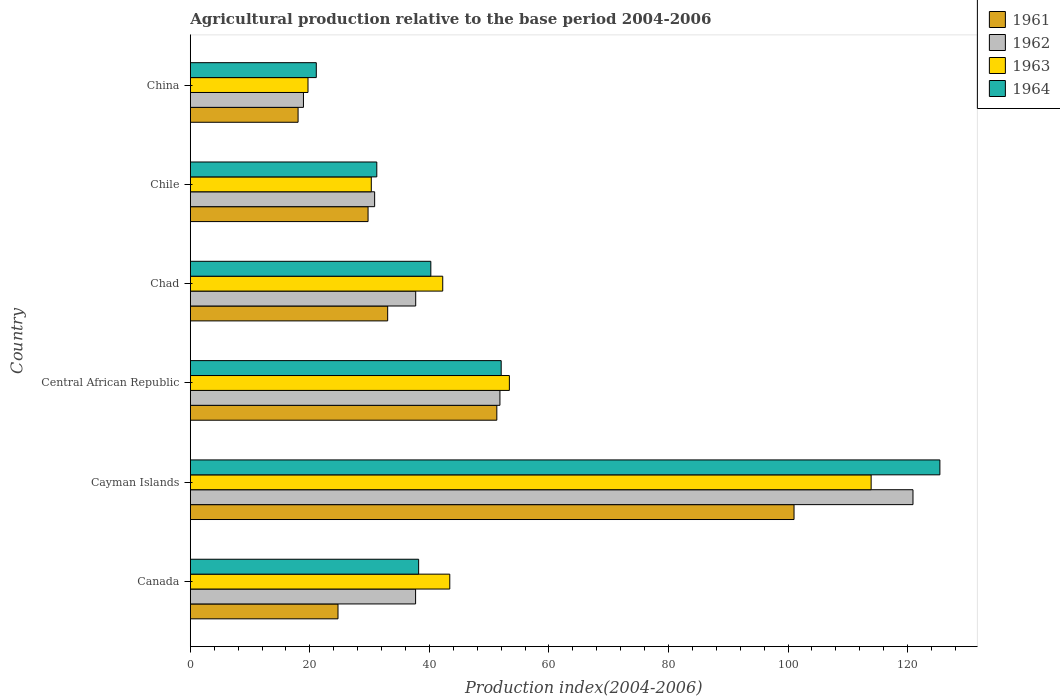How many different coloured bars are there?
Make the answer very short. 4. How many groups of bars are there?
Your answer should be compact. 6. Are the number of bars on each tick of the Y-axis equal?
Keep it short and to the point. Yes. How many bars are there on the 4th tick from the top?
Ensure brevity in your answer.  4. What is the label of the 3rd group of bars from the top?
Offer a terse response. Chad. In how many cases, is the number of bars for a given country not equal to the number of legend labels?
Offer a terse response. 0. What is the agricultural production index in 1961 in Chad?
Provide a succinct answer. 33.02. Across all countries, what is the maximum agricultural production index in 1962?
Keep it short and to the point. 120.9. Across all countries, what is the minimum agricultural production index in 1962?
Your answer should be very brief. 18.93. In which country was the agricultural production index in 1964 maximum?
Provide a succinct answer. Cayman Islands. In which country was the agricultural production index in 1963 minimum?
Offer a very short reply. China. What is the total agricultural production index in 1961 in the graph?
Offer a terse response. 257.78. What is the difference between the agricultural production index in 1962 in Cayman Islands and that in China?
Make the answer very short. 101.97. What is the difference between the agricultural production index in 1963 in Chile and the agricultural production index in 1961 in Central African Republic?
Ensure brevity in your answer.  -21. What is the average agricultural production index in 1963 per country?
Your answer should be very brief. 50.48. What is the difference between the agricultural production index in 1964 and agricultural production index in 1962 in China?
Your answer should be very brief. 2.15. In how many countries, is the agricultural production index in 1962 greater than 92 ?
Your answer should be very brief. 1. What is the ratio of the agricultural production index in 1962 in Cayman Islands to that in Chile?
Keep it short and to the point. 3.92. Is the agricultural production index in 1962 in Canada less than that in China?
Provide a short and direct response. No. Is the difference between the agricultural production index in 1964 in Cayman Islands and Chad greater than the difference between the agricultural production index in 1962 in Cayman Islands and Chad?
Your answer should be very brief. Yes. What is the difference between the highest and the second highest agricultural production index in 1963?
Provide a succinct answer. 60.52. What is the difference between the highest and the lowest agricultural production index in 1962?
Keep it short and to the point. 101.97. Is the sum of the agricultural production index in 1963 in Chad and China greater than the maximum agricultural production index in 1962 across all countries?
Ensure brevity in your answer.  No. Is it the case that in every country, the sum of the agricultural production index in 1963 and agricultural production index in 1962 is greater than the sum of agricultural production index in 1961 and agricultural production index in 1964?
Make the answer very short. No. What does the 2nd bar from the top in Central African Republic represents?
Keep it short and to the point. 1963. What does the 3rd bar from the bottom in Chad represents?
Give a very brief answer. 1963. How many bars are there?
Your response must be concise. 24. Are all the bars in the graph horizontal?
Your response must be concise. Yes. How many countries are there in the graph?
Your answer should be very brief. 6. What is the difference between two consecutive major ticks on the X-axis?
Your answer should be very brief. 20. How are the legend labels stacked?
Provide a succinct answer. Vertical. What is the title of the graph?
Offer a terse response. Agricultural production relative to the base period 2004-2006. Does "1965" appear as one of the legend labels in the graph?
Provide a short and direct response. No. What is the label or title of the X-axis?
Ensure brevity in your answer.  Production index(2004-2006). What is the label or title of the Y-axis?
Provide a succinct answer. Country. What is the Production index(2004-2006) of 1961 in Canada?
Provide a short and direct response. 24.71. What is the Production index(2004-2006) in 1962 in Canada?
Your answer should be very brief. 37.69. What is the Production index(2004-2006) of 1963 in Canada?
Keep it short and to the point. 43.41. What is the Production index(2004-2006) of 1964 in Canada?
Provide a succinct answer. 38.2. What is the Production index(2004-2006) in 1961 in Cayman Islands?
Offer a very short reply. 101. What is the Production index(2004-2006) of 1962 in Cayman Islands?
Your answer should be compact. 120.9. What is the Production index(2004-2006) in 1963 in Cayman Islands?
Offer a very short reply. 113.9. What is the Production index(2004-2006) of 1964 in Cayman Islands?
Your response must be concise. 125.4. What is the Production index(2004-2006) in 1961 in Central African Republic?
Your answer should be very brief. 51.28. What is the Production index(2004-2006) of 1962 in Central African Republic?
Offer a very short reply. 51.8. What is the Production index(2004-2006) of 1963 in Central African Republic?
Your response must be concise. 53.38. What is the Production index(2004-2006) in 1964 in Central African Republic?
Make the answer very short. 52.01. What is the Production index(2004-2006) in 1961 in Chad?
Keep it short and to the point. 33.02. What is the Production index(2004-2006) in 1962 in Chad?
Keep it short and to the point. 37.71. What is the Production index(2004-2006) of 1963 in Chad?
Give a very brief answer. 42.23. What is the Production index(2004-2006) in 1964 in Chad?
Offer a very short reply. 40.24. What is the Production index(2004-2006) of 1961 in Chile?
Make the answer very short. 29.74. What is the Production index(2004-2006) of 1962 in Chile?
Offer a terse response. 30.84. What is the Production index(2004-2006) in 1963 in Chile?
Your response must be concise. 30.28. What is the Production index(2004-2006) in 1964 in Chile?
Provide a short and direct response. 31.2. What is the Production index(2004-2006) of 1961 in China?
Offer a terse response. 18.03. What is the Production index(2004-2006) in 1962 in China?
Keep it short and to the point. 18.93. What is the Production index(2004-2006) in 1963 in China?
Provide a succinct answer. 19.69. What is the Production index(2004-2006) of 1964 in China?
Your answer should be compact. 21.08. Across all countries, what is the maximum Production index(2004-2006) of 1961?
Keep it short and to the point. 101. Across all countries, what is the maximum Production index(2004-2006) of 1962?
Offer a terse response. 120.9. Across all countries, what is the maximum Production index(2004-2006) in 1963?
Your answer should be compact. 113.9. Across all countries, what is the maximum Production index(2004-2006) of 1964?
Make the answer very short. 125.4. Across all countries, what is the minimum Production index(2004-2006) of 1961?
Keep it short and to the point. 18.03. Across all countries, what is the minimum Production index(2004-2006) in 1962?
Keep it short and to the point. 18.93. Across all countries, what is the minimum Production index(2004-2006) of 1963?
Provide a succinct answer. 19.69. Across all countries, what is the minimum Production index(2004-2006) in 1964?
Your answer should be very brief. 21.08. What is the total Production index(2004-2006) in 1961 in the graph?
Ensure brevity in your answer.  257.78. What is the total Production index(2004-2006) of 1962 in the graph?
Your answer should be compact. 297.87. What is the total Production index(2004-2006) of 1963 in the graph?
Offer a very short reply. 302.89. What is the total Production index(2004-2006) of 1964 in the graph?
Make the answer very short. 308.13. What is the difference between the Production index(2004-2006) in 1961 in Canada and that in Cayman Islands?
Ensure brevity in your answer.  -76.29. What is the difference between the Production index(2004-2006) in 1962 in Canada and that in Cayman Islands?
Keep it short and to the point. -83.21. What is the difference between the Production index(2004-2006) of 1963 in Canada and that in Cayman Islands?
Your answer should be very brief. -70.49. What is the difference between the Production index(2004-2006) in 1964 in Canada and that in Cayman Islands?
Your answer should be compact. -87.2. What is the difference between the Production index(2004-2006) in 1961 in Canada and that in Central African Republic?
Your answer should be very brief. -26.57. What is the difference between the Production index(2004-2006) of 1962 in Canada and that in Central African Republic?
Your answer should be compact. -14.11. What is the difference between the Production index(2004-2006) of 1963 in Canada and that in Central African Republic?
Keep it short and to the point. -9.97. What is the difference between the Production index(2004-2006) of 1964 in Canada and that in Central African Republic?
Your answer should be compact. -13.81. What is the difference between the Production index(2004-2006) in 1961 in Canada and that in Chad?
Provide a succinct answer. -8.31. What is the difference between the Production index(2004-2006) in 1962 in Canada and that in Chad?
Provide a short and direct response. -0.02. What is the difference between the Production index(2004-2006) of 1963 in Canada and that in Chad?
Offer a terse response. 1.18. What is the difference between the Production index(2004-2006) of 1964 in Canada and that in Chad?
Offer a terse response. -2.04. What is the difference between the Production index(2004-2006) in 1961 in Canada and that in Chile?
Make the answer very short. -5.03. What is the difference between the Production index(2004-2006) of 1962 in Canada and that in Chile?
Ensure brevity in your answer.  6.85. What is the difference between the Production index(2004-2006) in 1963 in Canada and that in Chile?
Give a very brief answer. 13.13. What is the difference between the Production index(2004-2006) of 1964 in Canada and that in Chile?
Ensure brevity in your answer.  7. What is the difference between the Production index(2004-2006) of 1961 in Canada and that in China?
Provide a succinct answer. 6.68. What is the difference between the Production index(2004-2006) of 1962 in Canada and that in China?
Offer a very short reply. 18.76. What is the difference between the Production index(2004-2006) of 1963 in Canada and that in China?
Offer a terse response. 23.72. What is the difference between the Production index(2004-2006) in 1964 in Canada and that in China?
Your answer should be very brief. 17.12. What is the difference between the Production index(2004-2006) in 1961 in Cayman Islands and that in Central African Republic?
Provide a short and direct response. 49.72. What is the difference between the Production index(2004-2006) in 1962 in Cayman Islands and that in Central African Republic?
Provide a short and direct response. 69.1. What is the difference between the Production index(2004-2006) of 1963 in Cayman Islands and that in Central African Republic?
Offer a very short reply. 60.52. What is the difference between the Production index(2004-2006) of 1964 in Cayman Islands and that in Central African Republic?
Offer a terse response. 73.39. What is the difference between the Production index(2004-2006) in 1961 in Cayman Islands and that in Chad?
Ensure brevity in your answer.  67.98. What is the difference between the Production index(2004-2006) in 1962 in Cayman Islands and that in Chad?
Give a very brief answer. 83.19. What is the difference between the Production index(2004-2006) of 1963 in Cayman Islands and that in Chad?
Ensure brevity in your answer.  71.67. What is the difference between the Production index(2004-2006) of 1964 in Cayman Islands and that in Chad?
Ensure brevity in your answer.  85.16. What is the difference between the Production index(2004-2006) of 1961 in Cayman Islands and that in Chile?
Your response must be concise. 71.26. What is the difference between the Production index(2004-2006) in 1962 in Cayman Islands and that in Chile?
Make the answer very short. 90.06. What is the difference between the Production index(2004-2006) in 1963 in Cayman Islands and that in Chile?
Offer a terse response. 83.62. What is the difference between the Production index(2004-2006) in 1964 in Cayman Islands and that in Chile?
Your answer should be very brief. 94.2. What is the difference between the Production index(2004-2006) of 1961 in Cayman Islands and that in China?
Your response must be concise. 82.97. What is the difference between the Production index(2004-2006) in 1962 in Cayman Islands and that in China?
Give a very brief answer. 101.97. What is the difference between the Production index(2004-2006) of 1963 in Cayman Islands and that in China?
Keep it short and to the point. 94.21. What is the difference between the Production index(2004-2006) in 1964 in Cayman Islands and that in China?
Your answer should be compact. 104.32. What is the difference between the Production index(2004-2006) in 1961 in Central African Republic and that in Chad?
Your response must be concise. 18.26. What is the difference between the Production index(2004-2006) in 1962 in Central African Republic and that in Chad?
Provide a succinct answer. 14.09. What is the difference between the Production index(2004-2006) in 1963 in Central African Republic and that in Chad?
Your answer should be compact. 11.15. What is the difference between the Production index(2004-2006) of 1964 in Central African Republic and that in Chad?
Give a very brief answer. 11.77. What is the difference between the Production index(2004-2006) of 1961 in Central African Republic and that in Chile?
Provide a succinct answer. 21.54. What is the difference between the Production index(2004-2006) in 1962 in Central African Republic and that in Chile?
Provide a succinct answer. 20.96. What is the difference between the Production index(2004-2006) in 1963 in Central African Republic and that in Chile?
Your answer should be very brief. 23.1. What is the difference between the Production index(2004-2006) of 1964 in Central African Republic and that in Chile?
Keep it short and to the point. 20.81. What is the difference between the Production index(2004-2006) in 1961 in Central African Republic and that in China?
Give a very brief answer. 33.25. What is the difference between the Production index(2004-2006) in 1962 in Central African Republic and that in China?
Provide a short and direct response. 32.87. What is the difference between the Production index(2004-2006) in 1963 in Central African Republic and that in China?
Make the answer very short. 33.69. What is the difference between the Production index(2004-2006) of 1964 in Central African Republic and that in China?
Keep it short and to the point. 30.93. What is the difference between the Production index(2004-2006) in 1961 in Chad and that in Chile?
Your answer should be very brief. 3.28. What is the difference between the Production index(2004-2006) in 1962 in Chad and that in Chile?
Offer a terse response. 6.87. What is the difference between the Production index(2004-2006) in 1963 in Chad and that in Chile?
Keep it short and to the point. 11.95. What is the difference between the Production index(2004-2006) in 1964 in Chad and that in Chile?
Your answer should be very brief. 9.04. What is the difference between the Production index(2004-2006) in 1961 in Chad and that in China?
Make the answer very short. 14.99. What is the difference between the Production index(2004-2006) in 1962 in Chad and that in China?
Make the answer very short. 18.78. What is the difference between the Production index(2004-2006) of 1963 in Chad and that in China?
Provide a succinct answer. 22.54. What is the difference between the Production index(2004-2006) of 1964 in Chad and that in China?
Your answer should be very brief. 19.16. What is the difference between the Production index(2004-2006) of 1961 in Chile and that in China?
Offer a very short reply. 11.71. What is the difference between the Production index(2004-2006) in 1962 in Chile and that in China?
Keep it short and to the point. 11.91. What is the difference between the Production index(2004-2006) in 1963 in Chile and that in China?
Offer a terse response. 10.59. What is the difference between the Production index(2004-2006) of 1964 in Chile and that in China?
Provide a short and direct response. 10.12. What is the difference between the Production index(2004-2006) in 1961 in Canada and the Production index(2004-2006) in 1962 in Cayman Islands?
Provide a succinct answer. -96.19. What is the difference between the Production index(2004-2006) of 1961 in Canada and the Production index(2004-2006) of 1963 in Cayman Islands?
Offer a very short reply. -89.19. What is the difference between the Production index(2004-2006) in 1961 in Canada and the Production index(2004-2006) in 1964 in Cayman Islands?
Provide a succinct answer. -100.69. What is the difference between the Production index(2004-2006) of 1962 in Canada and the Production index(2004-2006) of 1963 in Cayman Islands?
Offer a terse response. -76.21. What is the difference between the Production index(2004-2006) in 1962 in Canada and the Production index(2004-2006) in 1964 in Cayman Islands?
Offer a very short reply. -87.71. What is the difference between the Production index(2004-2006) in 1963 in Canada and the Production index(2004-2006) in 1964 in Cayman Islands?
Offer a terse response. -81.99. What is the difference between the Production index(2004-2006) of 1961 in Canada and the Production index(2004-2006) of 1962 in Central African Republic?
Keep it short and to the point. -27.09. What is the difference between the Production index(2004-2006) of 1961 in Canada and the Production index(2004-2006) of 1963 in Central African Republic?
Keep it short and to the point. -28.67. What is the difference between the Production index(2004-2006) of 1961 in Canada and the Production index(2004-2006) of 1964 in Central African Republic?
Offer a very short reply. -27.3. What is the difference between the Production index(2004-2006) of 1962 in Canada and the Production index(2004-2006) of 1963 in Central African Republic?
Ensure brevity in your answer.  -15.69. What is the difference between the Production index(2004-2006) of 1962 in Canada and the Production index(2004-2006) of 1964 in Central African Republic?
Give a very brief answer. -14.32. What is the difference between the Production index(2004-2006) of 1963 in Canada and the Production index(2004-2006) of 1964 in Central African Republic?
Give a very brief answer. -8.6. What is the difference between the Production index(2004-2006) in 1961 in Canada and the Production index(2004-2006) in 1962 in Chad?
Offer a terse response. -13. What is the difference between the Production index(2004-2006) in 1961 in Canada and the Production index(2004-2006) in 1963 in Chad?
Keep it short and to the point. -17.52. What is the difference between the Production index(2004-2006) in 1961 in Canada and the Production index(2004-2006) in 1964 in Chad?
Offer a very short reply. -15.53. What is the difference between the Production index(2004-2006) in 1962 in Canada and the Production index(2004-2006) in 1963 in Chad?
Offer a terse response. -4.54. What is the difference between the Production index(2004-2006) in 1962 in Canada and the Production index(2004-2006) in 1964 in Chad?
Provide a short and direct response. -2.55. What is the difference between the Production index(2004-2006) of 1963 in Canada and the Production index(2004-2006) of 1964 in Chad?
Your response must be concise. 3.17. What is the difference between the Production index(2004-2006) in 1961 in Canada and the Production index(2004-2006) in 1962 in Chile?
Your answer should be very brief. -6.13. What is the difference between the Production index(2004-2006) of 1961 in Canada and the Production index(2004-2006) of 1963 in Chile?
Offer a very short reply. -5.57. What is the difference between the Production index(2004-2006) of 1961 in Canada and the Production index(2004-2006) of 1964 in Chile?
Your answer should be compact. -6.49. What is the difference between the Production index(2004-2006) in 1962 in Canada and the Production index(2004-2006) in 1963 in Chile?
Give a very brief answer. 7.41. What is the difference between the Production index(2004-2006) in 1962 in Canada and the Production index(2004-2006) in 1964 in Chile?
Ensure brevity in your answer.  6.49. What is the difference between the Production index(2004-2006) of 1963 in Canada and the Production index(2004-2006) of 1964 in Chile?
Your response must be concise. 12.21. What is the difference between the Production index(2004-2006) in 1961 in Canada and the Production index(2004-2006) in 1962 in China?
Make the answer very short. 5.78. What is the difference between the Production index(2004-2006) of 1961 in Canada and the Production index(2004-2006) of 1963 in China?
Ensure brevity in your answer.  5.02. What is the difference between the Production index(2004-2006) in 1961 in Canada and the Production index(2004-2006) in 1964 in China?
Your answer should be compact. 3.63. What is the difference between the Production index(2004-2006) in 1962 in Canada and the Production index(2004-2006) in 1964 in China?
Your response must be concise. 16.61. What is the difference between the Production index(2004-2006) of 1963 in Canada and the Production index(2004-2006) of 1964 in China?
Your answer should be compact. 22.33. What is the difference between the Production index(2004-2006) in 1961 in Cayman Islands and the Production index(2004-2006) in 1962 in Central African Republic?
Your answer should be compact. 49.2. What is the difference between the Production index(2004-2006) in 1961 in Cayman Islands and the Production index(2004-2006) in 1963 in Central African Republic?
Your answer should be compact. 47.62. What is the difference between the Production index(2004-2006) in 1961 in Cayman Islands and the Production index(2004-2006) in 1964 in Central African Republic?
Your answer should be compact. 48.99. What is the difference between the Production index(2004-2006) in 1962 in Cayman Islands and the Production index(2004-2006) in 1963 in Central African Republic?
Ensure brevity in your answer.  67.52. What is the difference between the Production index(2004-2006) in 1962 in Cayman Islands and the Production index(2004-2006) in 1964 in Central African Republic?
Offer a very short reply. 68.89. What is the difference between the Production index(2004-2006) in 1963 in Cayman Islands and the Production index(2004-2006) in 1964 in Central African Republic?
Provide a succinct answer. 61.89. What is the difference between the Production index(2004-2006) in 1961 in Cayman Islands and the Production index(2004-2006) in 1962 in Chad?
Keep it short and to the point. 63.29. What is the difference between the Production index(2004-2006) in 1961 in Cayman Islands and the Production index(2004-2006) in 1963 in Chad?
Your answer should be compact. 58.77. What is the difference between the Production index(2004-2006) in 1961 in Cayman Islands and the Production index(2004-2006) in 1964 in Chad?
Make the answer very short. 60.76. What is the difference between the Production index(2004-2006) in 1962 in Cayman Islands and the Production index(2004-2006) in 1963 in Chad?
Keep it short and to the point. 78.67. What is the difference between the Production index(2004-2006) of 1962 in Cayman Islands and the Production index(2004-2006) of 1964 in Chad?
Give a very brief answer. 80.66. What is the difference between the Production index(2004-2006) of 1963 in Cayman Islands and the Production index(2004-2006) of 1964 in Chad?
Provide a succinct answer. 73.66. What is the difference between the Production index(2004-2006) in 1961 in Cayman Islands and the Production index(2004-2006) in 1962 in Chile?
Give a very brief answer. 70.16. What is the difference between the Production index(2004-2006) in 1961 in Cayman Islands and the Production index(2004-2006) in 1963 in Chile?
Make the answer very short. 70.72. What is the difference between the Production index(2004-2006) of 1961 in Cayman Islands and the Production index(2004-2006) of 1964 in Chile?
Offer a terse response. 69.8. What is the difference between the Production index(2004-2006) of 1962 in Cayman Islands and the Production index(2004-2006) of 1963 in Chile?
Make the answer very short. 90.62. What is the difference between the Production index(2004-2006) of 1962 in Cayman Islands and the Production index(2004-2006) of 1964 in Chile?
Offer a terse response. 89.7. What is the difference between the Production index(2004-2006) in 1963 in Cayman Islands and the Production index(2004-2006) in 1964 in Chile?
Provide a short and direct response. 82.7. What is the difference between the Production index(2004-2006) of 1961 in Cayman Islands and the Production index(2004-2006) of 1962 in China?
Offer a terse response. 82.07. What is the difference between the Production index(2004-2006) in 1961 in Cayman Islands and the Production index(2004-2006) in 1963 in China?
Your response must be concise. 81.31. What is the difference between the Production index(2004-2006) in 1961 in Cayman Islands and the Production index(2004-2006) in 1964 in China?
Make the answer very short. 79.92. What is the difference between the Production index(2004-2006) of 1962 in Cayman Islands and the Production index(2004-2006) of 1963 in China?
Provide a succinct answer. 101.21. What is the difference between the Production index(2004-2006) in 1962 in Cayman Islands and the Production index(2004-2006) in 1964 in China?
Provide a short and direct response. 99.82. What is the difference between the Production index(2004-2006) of 1963 in Cayman Islands and the Production index(2004-2006) of 1964 in China?
Your answer should be very brief. 92.82. What is the difference between the Production index(2004-2006) of 1961 in Central African Republic and the Production index(2004-2006) of 1962 in Chad?
Provide a short and direct response. 13.57. What is the difference between the Production index(2004-2006) of 1961 in Central African Republic and the Production index(2004-2006) of 1963 in Chad?
Offer a terse response. 9.05. What is the difference between the Production index(2004-2006) in 1961 in Central African Republic and the Production index(2004-2006) in 1964 in Chad?
Make the answer very short. 11.04. What is the difference between the Production index(2004-2006) of 1962 in Central African Republic and the Production index(2004-2006) of 1963 in Chad?
Keep it short and to the point. 9.57. What is the difference between the Production index(2004-2006) in 1962 in Central African Republic and the Production index(2004-2006) in 1964 in Chad?
Keep it short and to the point. 11.56. What is the difference between the Production index(2004-2006) of 1963 in Central African Republic and the Production index(2004-2006) of 1964 in Chad?
Offer a terse response. 13.14. What is the difference between the Production index(2004-2006) in 1961 in Central African Republic and the Production index(2004-2006) in 1962 in Chile?
Make the answer very short. 20.44. What is the difference between the Production index(2004-2006) in 1961 in Central African Republic and the Production index(2004-2006) in 1963 in Chile?
Give a very brief answer. 21. What is the difference between the Production index(2004-2006) in 1961 in Central African Republic and the Production index(2004-2006) in 1964 in Chile?
Your answer should be compact. 20.08. What is the difference between the Production index(2004-2006) of 1962 in Central African Republic and the Production index(2004-2006) of 1963 in Chile?
Give a very brief answer. 21.52. What is the difference between the Production index(2004-2006) of 1962 in Central African Republic and the Production index(2004-2006) of 1964 in Chile?
Your answer should be very brief. 20.6. What is the difference between the Production index(2004-2006) in 1963 in Central African Republic and the Production index(2004-2006) in 1964 in Chile?
Your response must be concise. 22.18. What is the difference between the Production index(2004-2006) of 1961 in Central African Republic and the Production index(2004-2006) of 1962 in China?
Offer a very short reply. 32.35. What is the difference between the Production index(2004-2006) in 1961 in Central African Republic and the Production index(2004-2006) in 1963 in China?
Your answer should be very brief. 31.59. What is the difference between the Production index(2004-2006) in 1961 in Central African Republic and the Production index(2004-2006) in 1964 in China?
Give a very brief answer. 30.2. What is the difference between the Production index(2004-2006) of 1962 in Central African Republic and the Production index(2004-2006) of 1963 in China?
Ensure brevity in your answer.  32.11. What is the difference between the Production index(2004-2006) of 1962 in Central African Republic and the Production index(2004-2006) of 1964 in China?
Ensure brevity in your answer.  30.72. What is the difference between the Production index(2004-2006) in 1963 in Central African Republic and the Production index(2004-2006) in 1964 in China?
Offer a very short reply. 32.3. What is the difference between the Production index(2004-2006) of 1961 in Chad and the Production index(2004-2006) of 1962 in Chile?
Offer a very short reply. 2.18. What is the difference between the Production index(2004-2006) in 1961 in Chad and the Production index(2004-2006) in 1963 in Chile?
Provide a short and direct response. 2.74. What is the difference between the Production index(2004-2006) in 1961 in Chad and the Production index(2004-2006) in 1964 in Chile?
Make the answer very short. 1.82. What is the difference between the Production index(2004-2006) of 1962 in Chad and the Production index(2004-2006) of 1963 in Chile?
Your answer should be compact. 7.43. What is the difference between the Production index(2004-2006) of 1962 in Chad and the Production index(2004-2006) of 1964 in Chile?
Offer a terse response. 6.51. What is the difference between the Production index(2004-2006) of 1963 in Chad and the Production index(2004-2006) of 1964 in Chile?
Provide a short and direct response. 11.03. What is the difference between the Production index(2004-2006) of 1961 in Chad and the Production index(2004-2006) of 1962 in China?
Give a very brief answer. 14.09. What is the difference between the Production index(2004-2006) of 1961 in Chad and the Production index(2004-2006) of 1963 in China?
Give a very brief answer. 13.33. What is the difference between the Production index(2004-2006) of 1961 in Chad and the Production index(2004-2006) of 1964 in China?
Make the answer very short. 11.94. What is the difference between the Production index(2004-2006) of 1962 in Chad and the Production index(2004-2006) of 1963 in China?
Ensure brevity in your answer.  18.02. What is the difference between the Production index(2004-2006) in 1962 in Chad and the Production index(2004-2006) in 1964 in China?
Your answer should be compact. 16.63. What is the difference between the Production index(2004-2006) in 1963 in Chad and the Production index(2004-2006) in 1964 in China?
Your response must be concise. 21.15. What is the difference between the Production index(2004-2006) of 1961 in Chile and the Production index(2004-2006) of 1962 in China?
Your answer should be compact. 10.81. What is the difference between the Production index(2004-2006) in 1961 in Chile and the Production index(2004-2006) in 1963 in China?
Your answer should be very brief. 10.05. What is the difference between the Production index(2004-2006) in 1961 in Chile and the Production index(2004-2006) in 1964 in China?
Ensure brevity in your answer.  8.66. What is the difference between the Production index(2004-2006) of 1962 in Chile and the Production index(2004-2006) of 1963 in China?
Your response must be concise. 11.15. What is the difference between the Production index(2004-2006) of 1962 in Chile and the Production index(2004-2006) of 1964 in China?
Provide a short and direct response. 9.76. What is the difference between the Production index(2004-2006) of 1963 in Chile and the Production index(2004-2006) of 1964 in China?
Provide a short and direct response. 9.2. What is the average Production index(2004-2006) in 1961 per country?
Provide a succinct answer. 42.96. What is the average Production index(2004-2006) of 1962 per country?
Provide a succinct answer. 49.65. What is the average Production index(2004-2006) in 1963 per country?
Provide a succinct answer. 50.48. What is the average Production index(2004-2006) in 1964 per country?
Your answer should be compact. 51.35. What is the difference between the Production index(2004-2006) of 1961 and Production index(2004-2006) of 1962 in Canada?
Your answer should be very brief. -12.98. What is the difference between the Production index(2004-2006) of 1961 and Production index(2004-2006) of 1963 in Canada?
Give a very brief answer. -18.7. What is the difference between the Production index(2004-2006) in 1961 and Production index(2004-2006) in 1964 in Canada?
Your answer should be compact. -13.49. What is the difference between the Production index(2004-2006) of 1962 and Production index(2004-2006) of 1963 in Canada?
Make the answer very short. -5.72. What is the difference between the Production index(2004-2006) of 1962 and Production index(2004-2006) of 1964 in Canada?
Ensure brevity in your answer.  -0.51. What is the difference between the Production index(2004-2006) in 1963 and Production index(2004-2006) in 1964 in Canada?
Make the answer very short. 5.21. What is the difference between the Production index(2004-2006) of 1961 and Production index(2004-2006) of 1962 in Cayman Islands?
Ensure brevity in your answer.  -19.9. What is the difference between the Production index(2004-2006) in 1961 and Production index(2004-2006) in 1963 in Cayman Islands?
Ensure brevity in your answer.  -12.9. What is the difference between the Production index(2004-2006) in 1961 and Production index(2004-2006) in 1964 in Cayman Islands?
Offer a terse response. -24.4. What is the difference between the Production index(2004-2006) of 1962 and Production index(2004-2006) of 1963 in Cayman Islands?
Make the answer very short. 7. What is the difference between the Production index(2004-2006) of 1962 and Production index(2004-2006) of 1964 in Cayman Islands?
Provide a succinct answer. -4.5. What is the difference between the Production index(2004-2006) in 1961 and Production index(2004-2006) in 1962 in Central African Republic?
Your answer should be compact. -0.52. What is the difference between the Production index(2004-2006) of 1961 and Production index(2004-2006) of 1964 in Central African Republic?
Offer a very short reply. -0.73. What is the difference between the Production index(2004-2006) of 1962 and Production index(2004-2006) of 1963 in Central African Republic?
Your answer should be very brief. -1.58. What is the difference between the Production index(2004-2006) of 1962 and Production index(2004-2006) of 1964 in Central African Republic?
Offer a very short reply. -0.21. What is the difference between the Production index(2004-2006) of 1963 and Production index(2004-2006) of 1964 in Central African Republic?
Make the answer very short. 1.37. What is the difference between the Production index(2004-2006) of 1961 and Production index(2004-2006) of 1962 in Chad?
Your answer should be very brief. -4.69. What is the difference between the Production index(2004-2006) of 1961 and Production index(2004-2006) of 1963 in Chad?
Provide a short and direct response. -9.21. What is the difference between the Production index(2004-2006) of 1961 and Production index(2004-2006) of 1964 in Chad?
Provide a succinct answer. -7.22. What is the difference between the Production index(2004-2006) of 1962 and Production index(2004-2006) of 1963 in Chad?
Your answer should be very brief. -4.52. What is the difference between the Production index(2004-2006) of 1962 and Production index(2004-2006) of 1964 in Chad?
Keep it short and to the point. -2.53. What is the difference between the Production index(2004-2006) of 1963 and Production index(2004-2006) of 1964 in Chad?
Offer a very short reply. 1.99. What is the difference between the Production index(2004-2006) of 1961 and Production index(2004-2006) of 1963 in Chile?
Provide a short and direct response. -0.54. What is the difference between the Production index(2004-2006) in 1961 and Production index(2004-2006) in 1964 in Chile?
Your answer should be very brief. -1.46. What is the difference between the Production index(2004-2006) of 1962 and Production index(2004-2006) of 1963 in Chile?
Give a very brief answer. 0.56. What is the difference between the Production index(2004-2006) of 1962 and Production index(2004-2006) of 1964 in Chile?
Ensure brevity in your answer.  -0.36. What is the difference between the Production index(2004-2006) in 1963 and Production index(2004-2006) in 1964 in Chile?
Ensure brevity in your answer.  -0.92. What is the difference between the Production index(2004-2006) in 1961 and Production index(2004-2006) in 1963 in China?
Keep it short and to the point. -1.66. What is the difference between the Production index(2004-2006) of 1961 and Production index(2004-2006) of 1964 in China?
Your answer should be very brief. -3.05. What is the difference between the Production index(2004-2006) of 1962 and Production index(2004-2006) of 1963 in China?
Your answer should be compact. -0.76. What is the difference between the Production index(2004-2006) of 1962 and Production index(2004-2006) of 1964 in China?
Offer a very short reply. -2.15. What is the difference between the Production index(2004-2006) of 1963 and Production index(2004-2006) of 1964 in China?
Offer a terse response. -1.39. What is the ratio of the Production index(2004-2006) of 1961 in Canada to that in Cayman Islands?
Provide a succinct answer. 0.24. What is the ratio of the Production index(2004-2006) in 1962 in Canada to that in Cayman Islands?
Your response must be concise. 0.31. What is the ratio of the Production index(2004-2006) in 1963 in Canada to that in Cayman Islands?
Provide a short and direct response. 0.38. What is the ratio of the Production index(2004-2006) in 1964 in Canada to that in Cayman Islands?
Your response must be concise. 0.3. What is the ratio of the Production index(2004-2006) in 1961 in Canada to that in Central African Republic?
Provide a succinct answer. 0.48. What is the ratio of the Production index(2004-2006) of 1962 in Canada to that in Central African Republic?
Offer a very short reply. 0.73. What is the ratio of the Production index(2004-2006) in 1963 in Canada to that in Central African Republic?
Ensure brevity in your answer.  0.81. What is the ratio of the Production index(2004-2006) in 1964 in Canada to that in Central African Republic?
Your response must be concise. 0.73. What is the ratio of the Production index(2004-2006) of 1961 in Canada to that in Chad?
Your answer should be compact. 0.75. What is the ratio of the Production index(2004-2006) of 1963 in Canada to that in Chad?
Your answer should be very brief. 1.03. What is the ratio of the Production index(2004-2006) in 1964 in Canada to that in Chad?
Give a very brief answer. 0.95. What is the ratio of the Production index(2004-2006) in 1961 in Canada to that in Chile?
Keep it short and to the point. 0.83. What is the ratio of the Production index(2004-2006) in 1962 in Canada to that in Chile?
Offer a terse response. 1.22. What is the ratio of the Production index(2004-2006) of 1963 in Canada to that in Chile?
Your answer should be compact. 1.43. What is the ratio of the Production index(2004-2006) in 1964 in Canada to that in Chile?
Give a very brief answer. 1.22. What is the ratio of the Production index(2004-2006) of 1961 in Canada to that in China?
Give a very brief answer. 1.37. What is the ratio of the Production index(2004-2006) of 1962 in Canada to that in China?
Offer a very short reply. 1.99. What is the ratio of the Production index(2004-2006) of 1963 in Canada to that in China?
Your answer should be very brief. 2.2. What is the ratio of the Production index(2004-2006) in 1964 in Canada to that in China?
Provide a succinct answer. 1.81. What is the ratio of the Production index(2004-2006) in 1961 in Cayman Islands to that in Central African Republic?
Offer a terse response. 1.97. What is the ratio of the Production index(2004-2006) in 1962 in Cayman Islands to that in Central African Republic?
Give a very brief answer. 2.33. What is the ratio of the Production index(2004-2006) of 1963 in Cayman Islands to that in Central African Republic?
Make the answer very short. 2.13. What is the ratio of the Production index(2004-2006) of 1964 in Cayman Islands to that in Central African Republic?
Your answer should be very brief. 2.41. What is the ratio of the Production index(2004-2006) in 1961 in Cayman Islands to that in Chad?
Offer a terse response. 3.06. What is the ratio of the Production index(2004-2006) in 1962 in Cayman Islands to that in Chad?
Your answer should be very brief. 3.21. What is the ratio of the Production index(2004-2006) in 1963 in Cayman Islands to that in Chad?
Your response must be concise. 2.7. What is the ratio of the Production index(2004-2006) in 1964 in Cayman Islands to that in Chad?
Keep it short and to the point. 3.12. What is the ratio of the Production index(2004-2006) in 1961 in Cayman Islands to that in Chile?
Your answer should be compact. 3.4. What is the ratio of the Production index(2004-2006) of 1962 in Cayman Islands to that in Chile?
Offer a very short reply. 3.92. What is the ratio of the Production index(2004-2006) of 1963 in Cayman Islands to that in Chile?
Give a very brief answer. 3.76. What is the ratio of the Production index(2004-2006) of 1964 in Cayman Islands to that in Chile?
Make the answer very short. 4.02. What is the ratio of the Production index(2004-2006) in 1961 in Cayman Islands to that in China?
Provide a short and direct response. 5.6. What is the ratio of the Production index(2004-2006) in 1962 in Cayman Islands to that in China?
Give a very brief answer. 6.39. What is the ratio of the Production index(2004-2006) of 1963 in Cayman Islands to that in China?
Keep it short and to the point. 5.78. What is the ratio of the Production index(2004-2006) in 1964 in Cayman Islands to that in China?
Offer a terse response. 5.95. What is the ratio of the Production index(2004-2006) of 1961 in Central African Republic to that in Chad?
Ensure brevity in your answer.  1.55. What is the ratio of the Production index(2004-2006) of 1962 in Central African Republic to that in Chad?
Provide a succinct answer. 1.37. What is the ratio of the Production index(2004-2006) in 1963 in Central African Republic to that in Chad?
Ensure brevity in your answer.  1.26. What is the ratio of the Production index(2004-2006) of 1964 in Central African Republic to that in Chad?
Give a very brief answer. 1.29. What is the ratio of the Production index(2004-2006) of 1961 in Central African Republic to that in Chile?
Provide a succinct answer. 1.72. What is the ratio of the Production index(2004-2006) in 1962 in Central African Republic to that in Chile?
Give a very brief answer. 1.68. What is the ratio of the Production index(2004-2006) in 1963 in Central African Republic to that in Chile?
Provide a short and direct response. 1.76. What is the ratio of the Production index(2004-2006) in 1964 in Central African Republic to that in Chile?
Offer a terse response. 1.67. What is the ratio of the Production index(2004-2006) of 1961 in Central African Republic to that in China?
Offer a very short reply. 2.84. What is the ratio of the Production index(2004-2006) in 1962 in Central African Republic to that in China?
Offer a very short reply. 2.74. What is the ratio of the Production index(2004-2006) of 1963 in Central African Republic to that in China?
Provide a succinct answer. 2.71. What is the ratio of the Production index(2004-2006) of 1964 in Central African Republic to that in China?
Provide a succinct answer. 2.47. What is the ratio of the Production index(2004-2006) of 1961 in Chad to that in Chile?
Make the answer very short. 1.11. What is the ratio of the Production index(2004-2006) of 1962 in Chad to that in Chile?
Your response must be concise. 1.22. What is the ratio of the Production index(2004-2006) in 1963 in Chad to that in Chile?
Make the answer very short. 1.39. What is the ratio of the Production index(2004-2006) in 1964 in Chad to that in Chile?
Give a very brief answer. 1.29. What is the ratio of the Production index(2004-2006) in 1961 in Chad to that in China?
Provide a short and direct response. 1.83. What is the ratio of the Production index(2004-2006) of 1962 in Chad to that in China?
Your response must be concise. 1.99. What is the ratio of the Production index(2004-2006) in 1963 in Chad to that in China?
Provide a short and direct response. 2.14. What is the ratio of the Production index(2004-2006) of 1964 in Chad to that in China?
Provide a short and direct response. 1.91. What is the ratio of the Production index(2004-2006) in 1961 in Chile to that in China?
Make the answer very short. 1.65. What is the ratio of the Production index(2004-2006) in 1962 in Chile to that in China?
Keep it short and to the point. 1.63. What is the ratio of the Production index(2004-2006) in 1963 in Chile to that in China?
Ensure brevity in your answer.  1.54. What is the ratio of the Production index(2004-2006) in 1964 in Chile to that in China?
Make the answer very short. 1.48. What is the difference between the highest and the second highest Production index(2004-2006) in 1961?
Your answer should be compact. 49.72. What is the difference between the highest and the second highest Production index(2004-2006) of 1962?
Keep it short and to the point. 69.1. What is the difference between the highest and the second highest Production index(2004-2006) in 1963?
Make the answer very short. 60.52. What is the difference between the highest and the second highest Production index(2004-2006) of 1964?
Keep it short and to the point. 73.39. What is the difference between the highest and the lowest Production index(2004-2006) in 1961?
Ensure brevity in your answer.  82.97. What is the difference between the highest and the lowest Production index(2004-2006) in 1962?
Provide a short and direct response. 101.97. What is the difference between the highest and the lowest Production index(2004-2006) of 1963?
Ensure brevity in your answer.  94.21. What is the difference between the highest and the lowest Production index(2004-2006) in 1964?
Offer a very short reply. 104.32. 